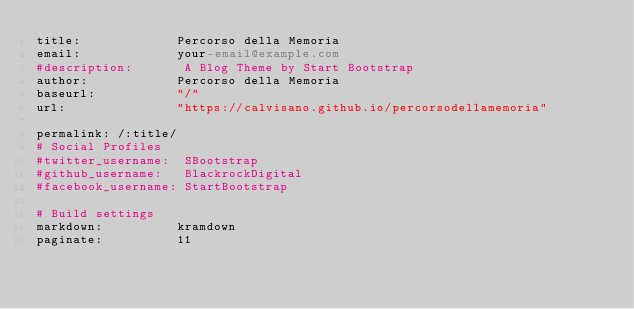<code> <loc_0><loc_0><loc_500><loc_500><_YAML_>title:             Percorso della Memoria
email:             your-email@example.com
#description:       A Blog Theme by Start Bootstrap
author:            Percorso della Memoria
baseurl:           "/"
url:               "https://calvisano.github.io/percorsodellamemoria"

permalink: /:title/
# Social Profiles
#twitter_username:  SBootstrap
#github_username:   BlackrockDigital
#facebook_username: StartBootstrap

# Build settings
markdown:          kramdown
paginate:          11</code> 